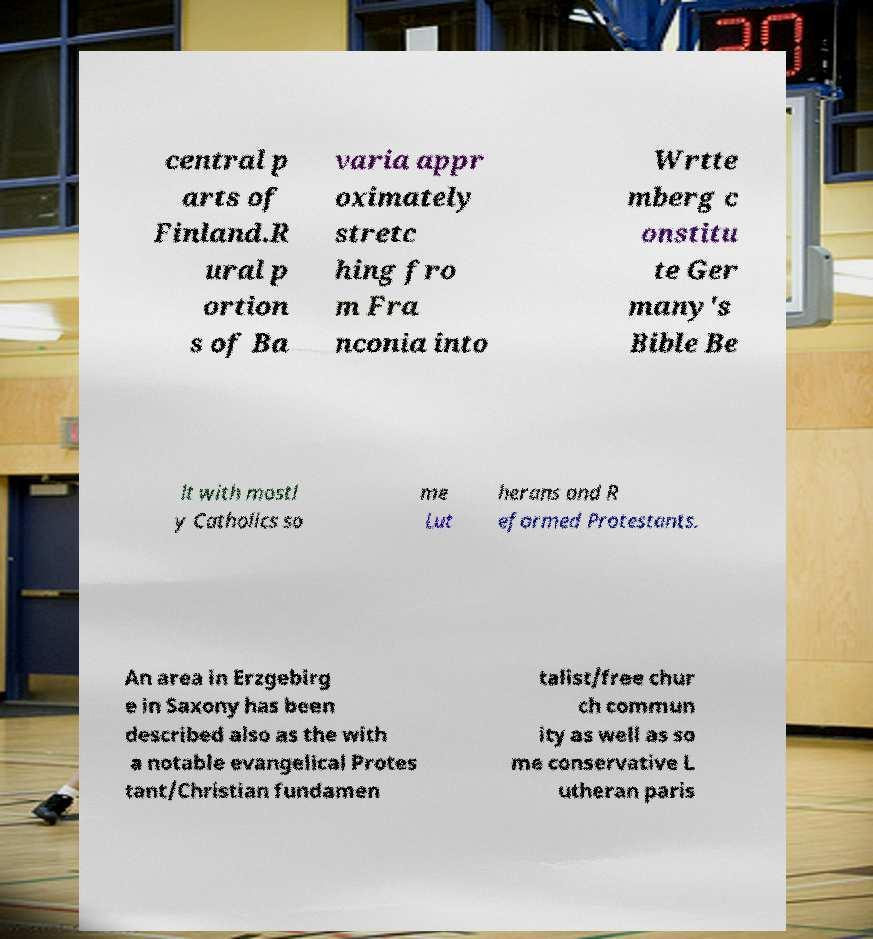Can you read and provide the text displayed in the image?This photo seems to have some interesting text. Can you extract and type it out for me? central p arts of Finland.R ural p ortion s of Ba varia appr oximately stretc hing fro m Fra nconia into Wrtte mberg c onstitu te Ger many's Bible Be lt with mostl y Catholics so me Lut herans and R eformed Protestants. An area in Erzgebirg e in Saxony has been described also as the with a notable evangelical Protes tant/Christian fundamen talist/free chur ch commun ity as well as so me conservative L utheran paris 